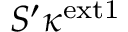Convert formula to latex. <formula><loc_0><loc_0><loc_500><loc_500>S ^ { \prime } \kappa ^ { e x t 1 }</formula> 